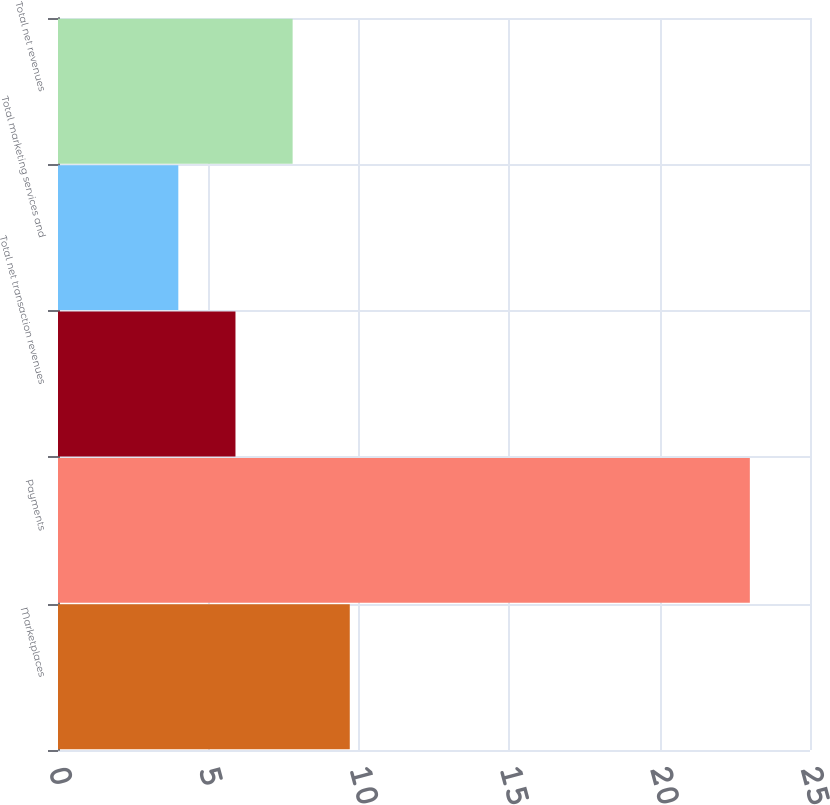Convert chart. <chart><loc_0><loc_0><loc_500><loc_500><bar_chart><fcel>Marketplaces<fcel>Payments<fcel>Total net transaction revenues<fcel>Total marketing services and<fcel>Total net revenues<nl><fcel>9.7<fcel>23<fcel>5.9<fcel>4<fcel>7.8<nl></chart> 